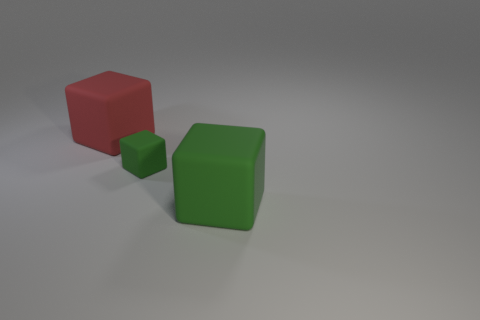Add 2 tiny green blocks. How many objects exist? 5 Subtract all green rubber spheres. Subtract all big matte blocks. How many objects are left? 1 Add 1 red objects. How many red objects are left? 2 Add 3 red matte things. How many red matte things exist? 4 Subtract 0 yellow spheres. How many objects are left? 3 